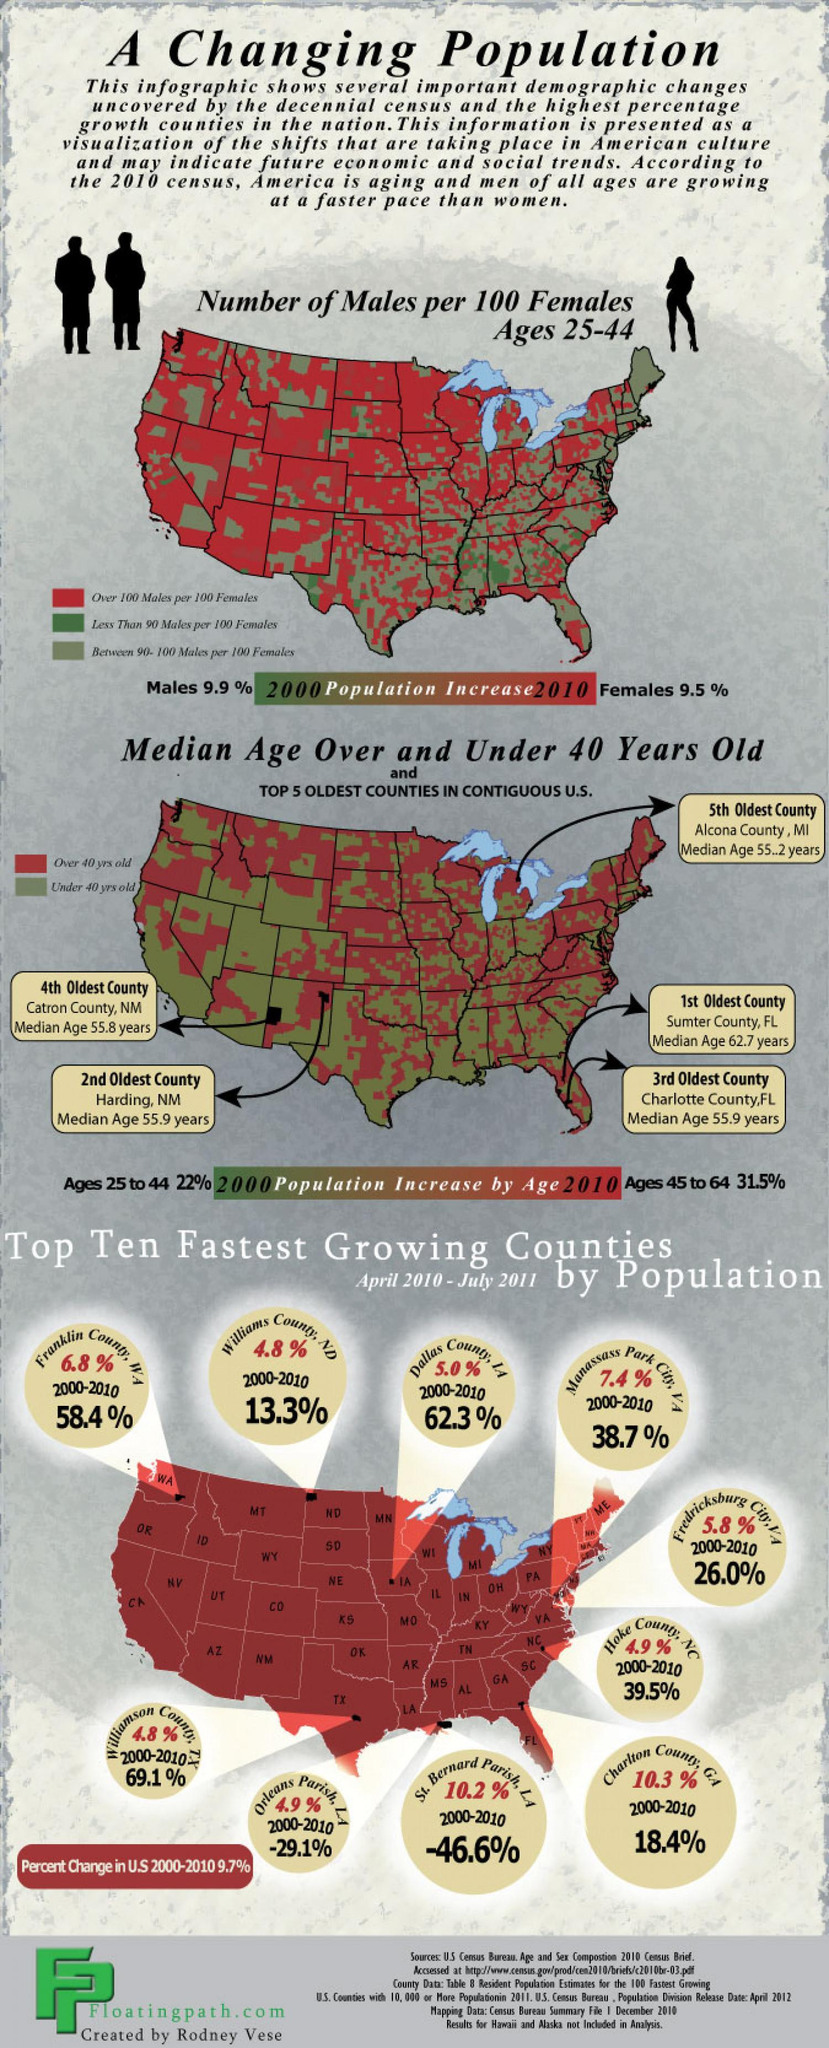What is the percent change in the population of Williams County in North Dakota during 2000-2010?
Answer the question with a short phrase. 13.3% What is the population growth rate in Dallas County during during April 2010 - July 2011? 5.0% Which county in North Carolina has the fastest growing population during April 2010 - July 2011? Hoke County, NC Which county in Texas has the fastest growing population during April 2010 - July 2011? Williamson County 